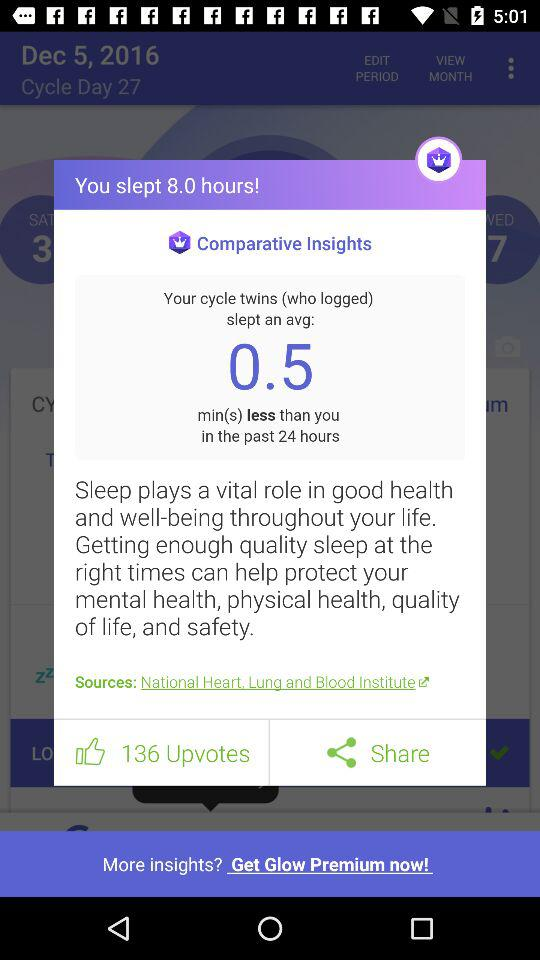What is the number of upvotes? The number of upvotes is 136. 